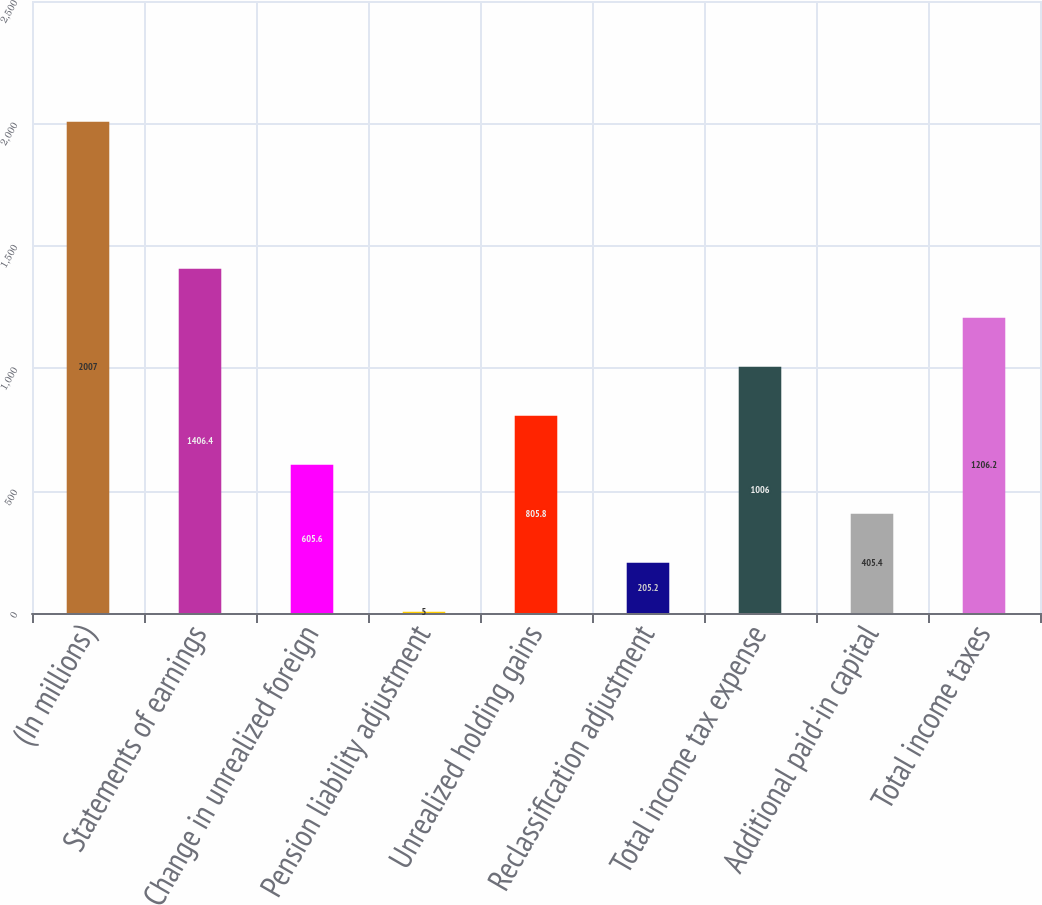Convert chart to OTSL. <chart><loc_0><loc_0><loc_500><loc_500><bar_chart><fcel>(In millions)<fcel>Statements of earnings<fcel>Change in unrealized foreign<fcel>Pension liability adjustment<fcel>Unrealized holding gains<fcel>Reclassification adjustment<fcel>Total income tax expense<fcel>Additional paid-in capital<fcel>Total income taxes<nl><fcel>2007<fcel>1406.4<fcel>605.6<fcel>5<fcel>805.8<fcel>205.2<fcel>1006<fcel>405.4<fcel>1206.2<nl></chart> 